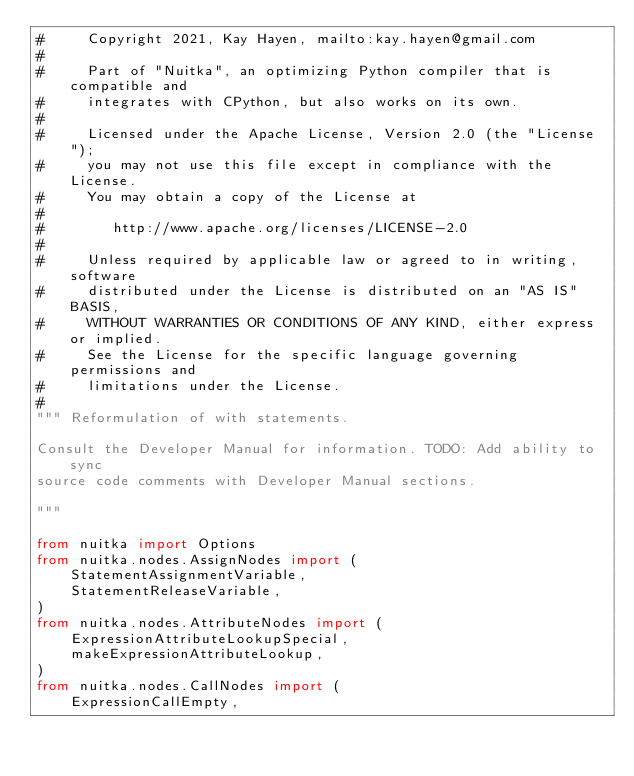<code> <loc_0><loc_0><loc_500><loc_500><_Python_>#     Copyright 2021, Kay Hayen, mailto:kay.hayen@gmail.com
#
#     Part of "Nuitka", an optimizing Python compiler that is compatible and
#     integrates with CPython, but also works on its own.
#
#     Licensed under the Apache License, Version 2.0 (the "License");
#     you may not use this file except in compliance with the License.
#     You may obtain a copy of the License at
#
#        http://www.apache.org/licenses/LICENSE-2.0
#
#     Unless required by applicable law or agreed to in writing, software
#     distributed under the License is distributed on an "AS IS" BASIS,
#     WITHOUT WARRANTIES OR CONDITIONS OF ANY KIND, either express or implied.
#     See the License for the specific language governing permissions and
#     limitations under the License.
#
""" Reformulation of with statements.

Consult the Developer Manual for information. TODO: Add ability to sync
source code comments with Developer Manual sections.

"""

from nuitka import Options
from nuitka.nodes.AssignNodes import (
    StatementAssignmentVariable,
    StatementReleaseVariable,
)
from nuitka.nodes.AttributeNodes import (
    ExpressionAttributeLookupSpecial,
    makeExpressionAttributeLookup,
)
from nuitka.nodes.CallNodes import (
    ExpressionCallEmpty,</code> 